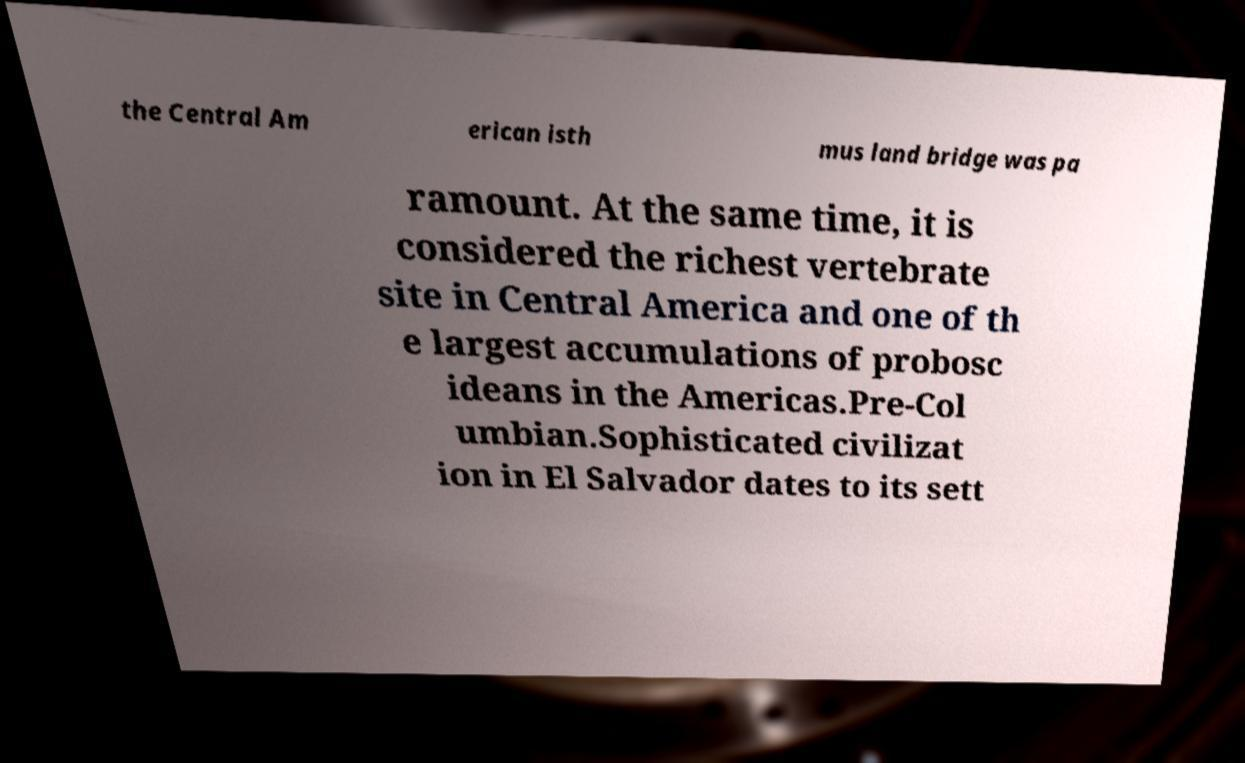What messages or text are displayed in this image? I need them in a readable, typed format. the Central Am erican isth mus land bridge was pa ramount. At the same time, it is considered the richest vertebrate site in Central America and one of th e largest accumulations of probosc ideans in the Americas.Pre-Col umbian.Sophisticated civilizat ion in El Salvador dates to its sett 